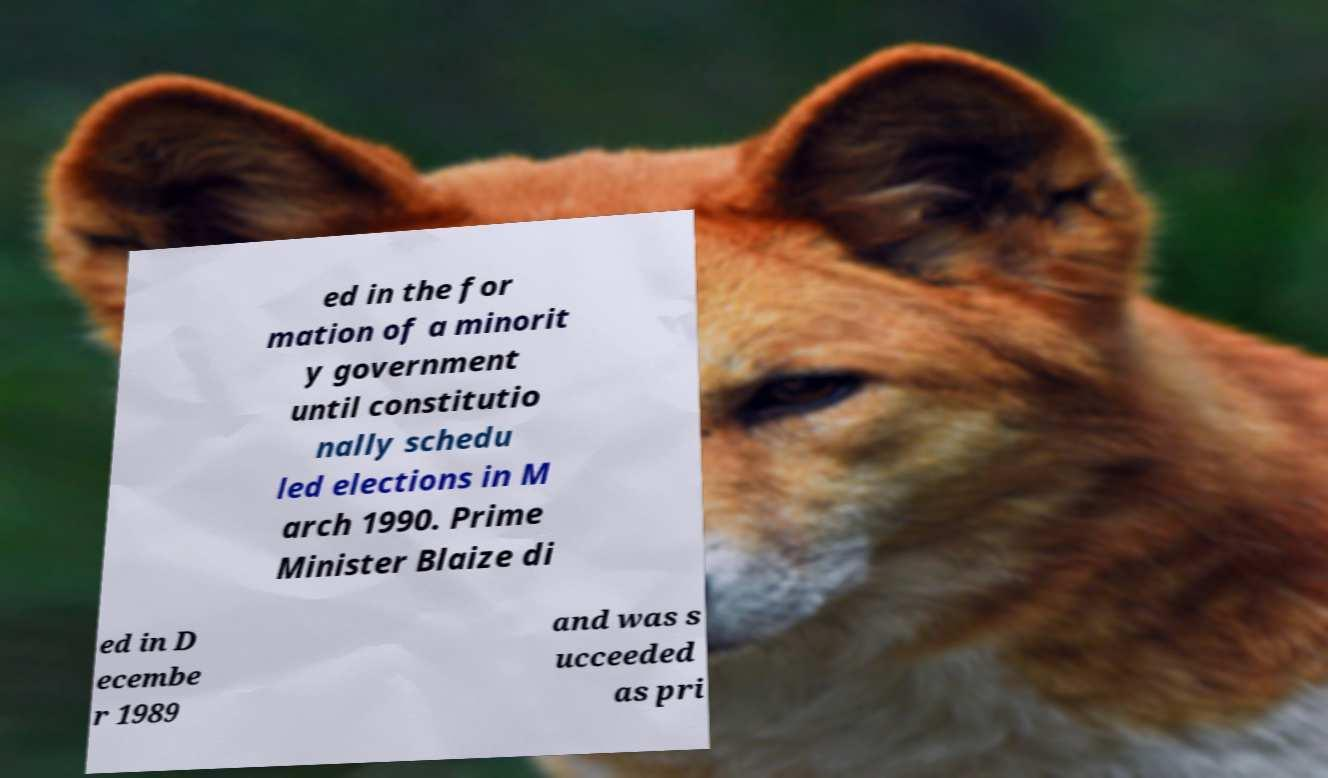For documentation purposes, I need the text within this image transcribed. Could you provide that? ed in the for mation of a minorit y government until constitutio nally schedu led elections in M arch 1990. Prime Minister Blaize di ed in D ecembe r 1989 and was s ucceeded as pri 